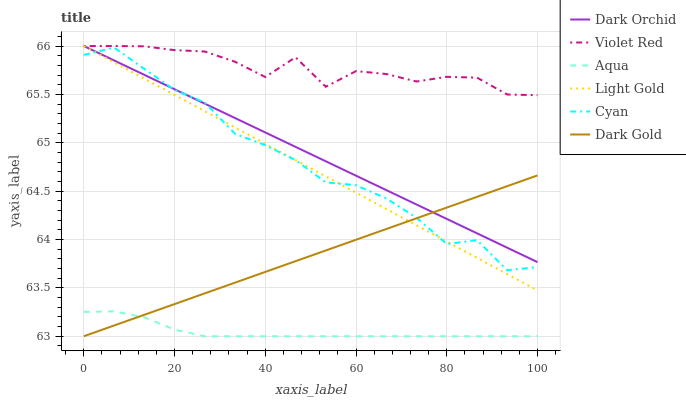Does Aqua have the minimum area under the curve?
Answer yes or no. Yes. Does Violet Red have the maximum area under the curve?
Answer yes or no. Yes. Does Dark Gold have the minimum area under the curve?
Answer yes or no. No. Does Dark Gold have the maximum area under the curve?
Answer yes or no. No. Is Light Gold the smoothest?
Answer yes or no. Yes. Is Cyan the roughest?
Answer yes or no. Yes. Is Dark Gold the smoothest?
Answer yes or no. No. Is Dark Gold the roughest?
Answer yes or no. No. Does Dark Gold have the lowest value?
Answer yes or no. Yes. Does Dark Orchid have the lowest value?
Answer yes or no. No. Does Light Gold have the highest value?
Answer yes or no. Yes. Does Dark Gold have the highest value?
Answer yes or no. No. Is Aqua less than Light Gold?
Answer yes or no. Yes. Is Cyan greater than Aqua?
Answer yes or no. Yes. Does Aqua intersect Dark Gold?
Answer yes or no. Yes. Is Aqua less than Dark Gold?
Answer yes or no. No. Is Aqua greater than Dark Gold?
Answer yes or no. No. Does Aqua intersect Light Gold?
Answer yes or no. No. 